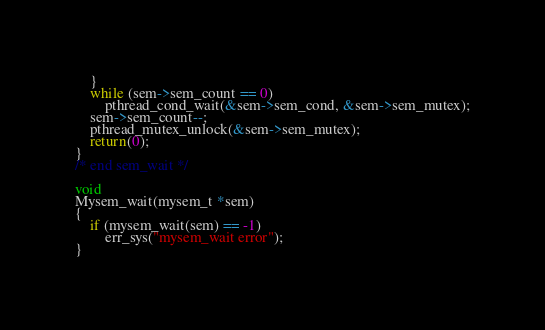Convert code to text. <code><loc_0><loc_0><loc_500><loc_500><_C_>	}
	while (sem->sem_count == 0)
		pthread_cond_wait(&sem->sem_cond, &sem->sem_mutex);
	sem->sem_count--;
	pthread_mutex_unlock(&sem->sem_mutex);
	return(0);
}
/* end sem_wait */

void
Mysem_wait(mysem_t *sem)
{
	if (mysem_wait(sem) == -1)
		err_sys("mysem_wait error");
}
</code> 